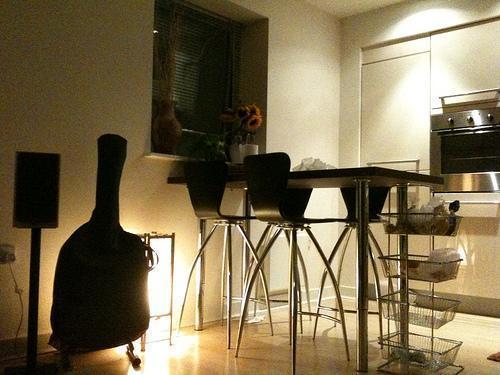What kind of musical instrument is covered by the guitar on the left side of the room?
Choose the correct response, then elucidate: 'Answer: answer
Rationale: rationale.'
Options: Guitar, piano, violin, bass. Answer: guitar.
Rationale: There is a guitar covered up by a wrapping on the left side. 